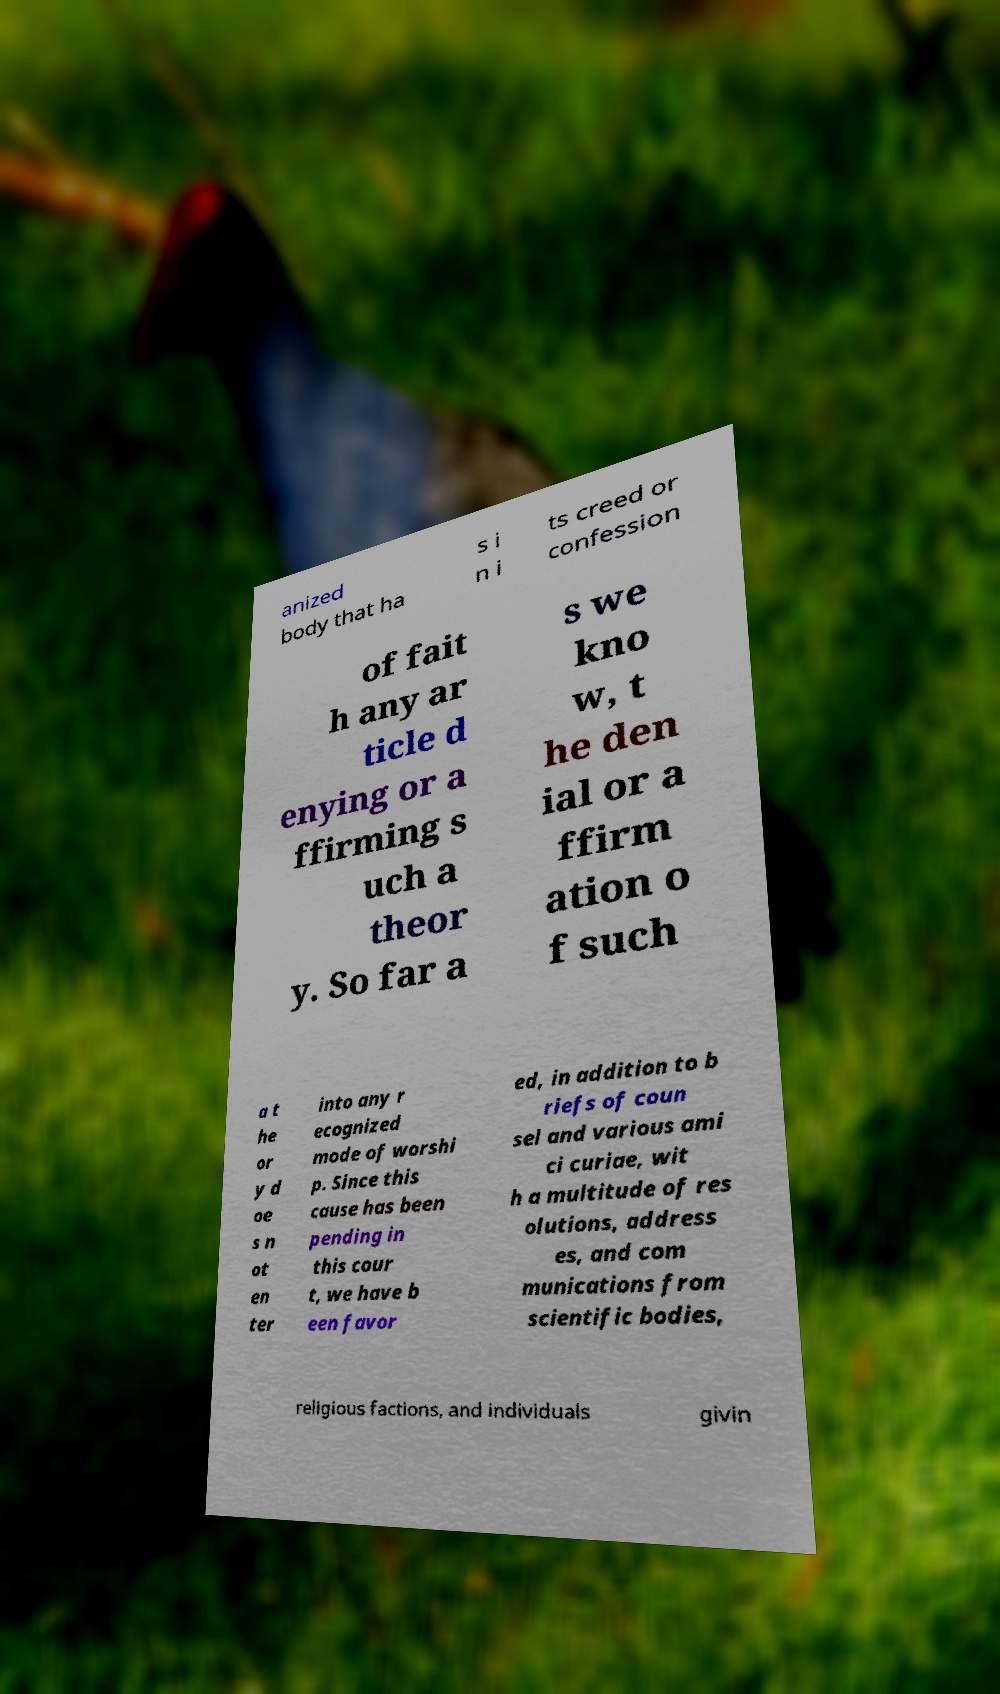Can you read and provide the text displayed in the image?This photo seems to have some interesting text. Can you extract and type it out for me? anized body that ha s i n i ts creed or confession of fait h any ar ticle d enying or a ffirming s uch a theor y. So far a s we kno w, t he den ial or a ffirm ation o f such a t he or y d oe s n ot en ter into any r ecognized mode of worshi p. Since this cause has been pending in this cour t, we have b een favor ed, in addition to b riefs of coun sel and various ami ci curiae, wit h a multitude of res olutions, address es, and com munications from scientific bodies, religious factions, and individuals givin 